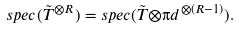Convert formula to latex. <formula><loc_0><loc_0><loc_500><loc_500>s p e c ( \tilde { T } ^ { { \otimes } R } ) = s p e c ( \tilde { T } { \otimes } { \i d } ^ { { \otimes } ( R - 1 ) } ) .</formula> 